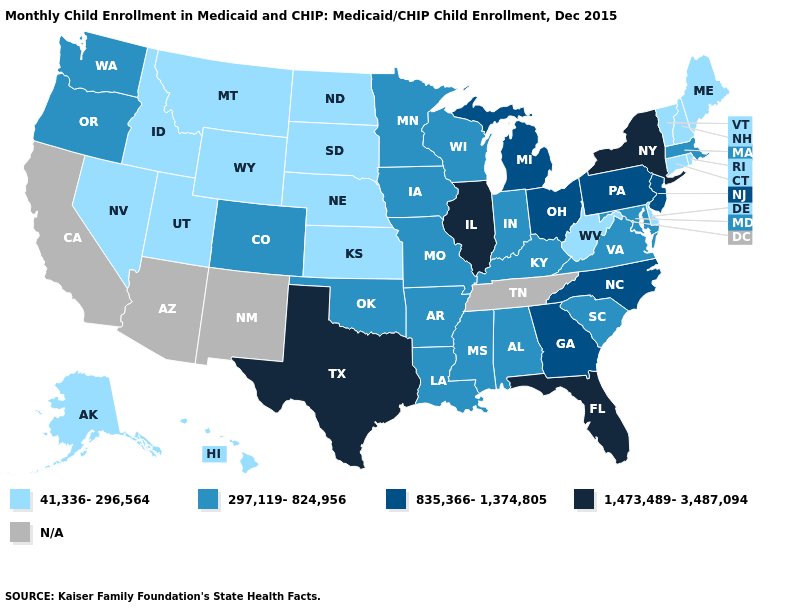Among the states that border New York , which have the highest value?
Concise answer only. New Jersey, Pennsylvania. What is the value of Missouri?
Answer briefly. 297,119-824,956. Name the states that have a value in the range N/A?
Concise answer only. Arizona, California, New Mexico, Tennessee. Does New Hampshire have the highest value in the Northeast?
Quick response, please. No. Name the states that have a value in the range 297,119-824,956?
Keep it brief. Alabama, Arkansas, Colorado, Indiana, Iowa, Kentucky, Louisiana, Maryland, Massachusetts, Minnesota, Mississippi, Missouri, Oklahoma, Oregon, South Carolina, Virginia, Washington, Wisconsin. Does the map have missing data?
Write a very short answer. Yes. What is the value of Kentucky?
Write a very short answer. 297,119-824,956. Which states have the lowest value in the Northeast?
Quick response, please. Connecticut, Maine, New Hampshire, Rhode Island, Vermont. Among the states that border New Mexico , which have the lowest value?
Quick response, please. Utah. Name the states that have a value in the range N/A?
Write a very short answer. Arizona, California, New Mexico, Tennessee. Does Massachusetts have the highest value in the USA?
Answer briefly. No. What is the value of South Dakota?
Quick response, please. 41,336-296,564. Does the map have missing data?
Write a very short answer. Yes. What is the value of Texas?
Answer briefly. 1,473,489-3,487,094. What is the highest value in the USA?
Quick response, please. 1,473,489-3,487,094. 